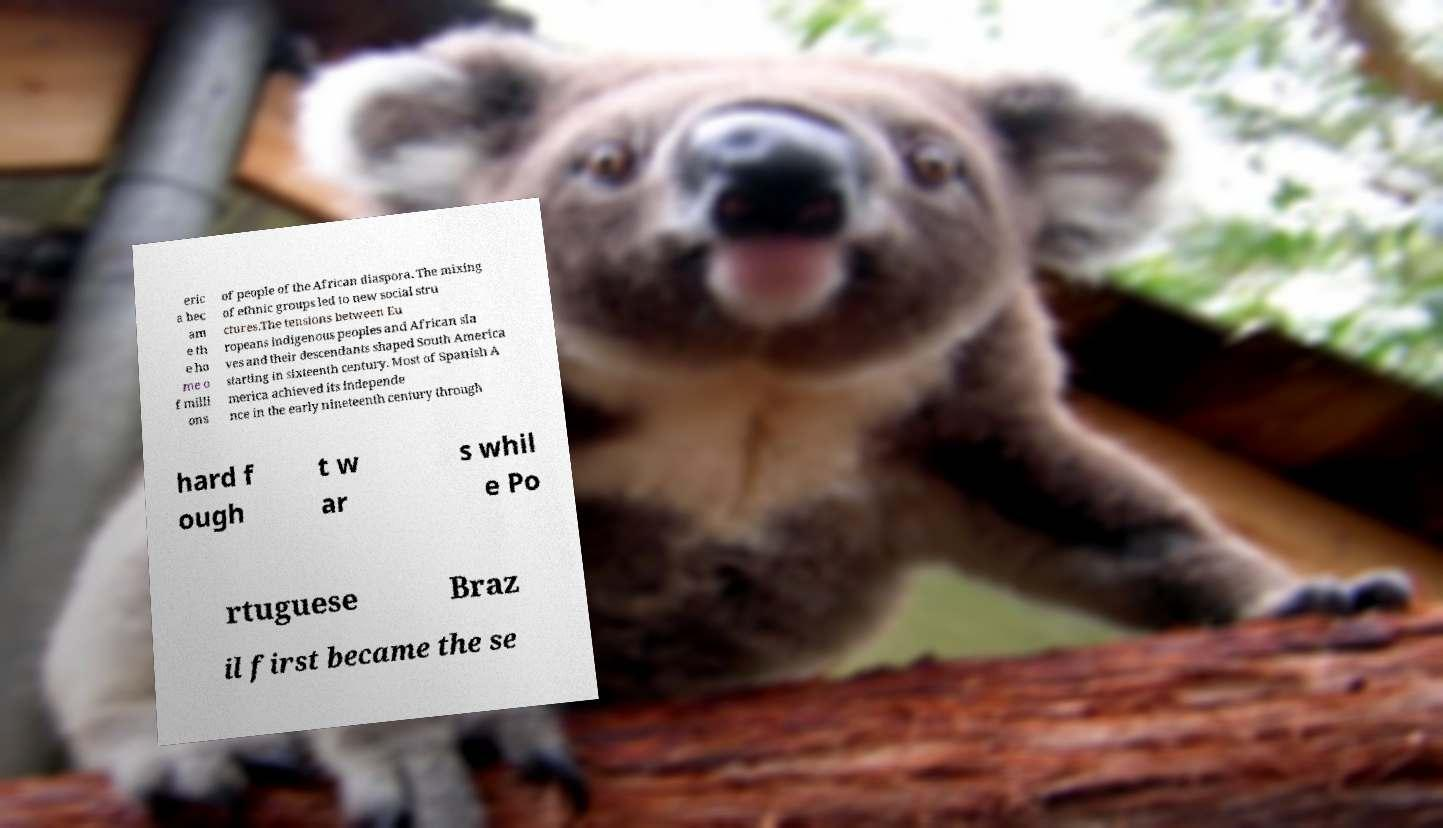Could you extract and type out the text from this image? eric a bec am e th e ho me o f milli ons of people of the African diaspora. The mixing of ethnic groups led to new social stru ctures.The tensions between Eu ropeans indigenous peoples and African sla ves and their descendants shaped South America starting in sixteenth century. Most of Spanish A merica achieved its independe nce in the early nineteenth century through hard f ough t w ar s whil e Po rtuguese Braz il first became the se 